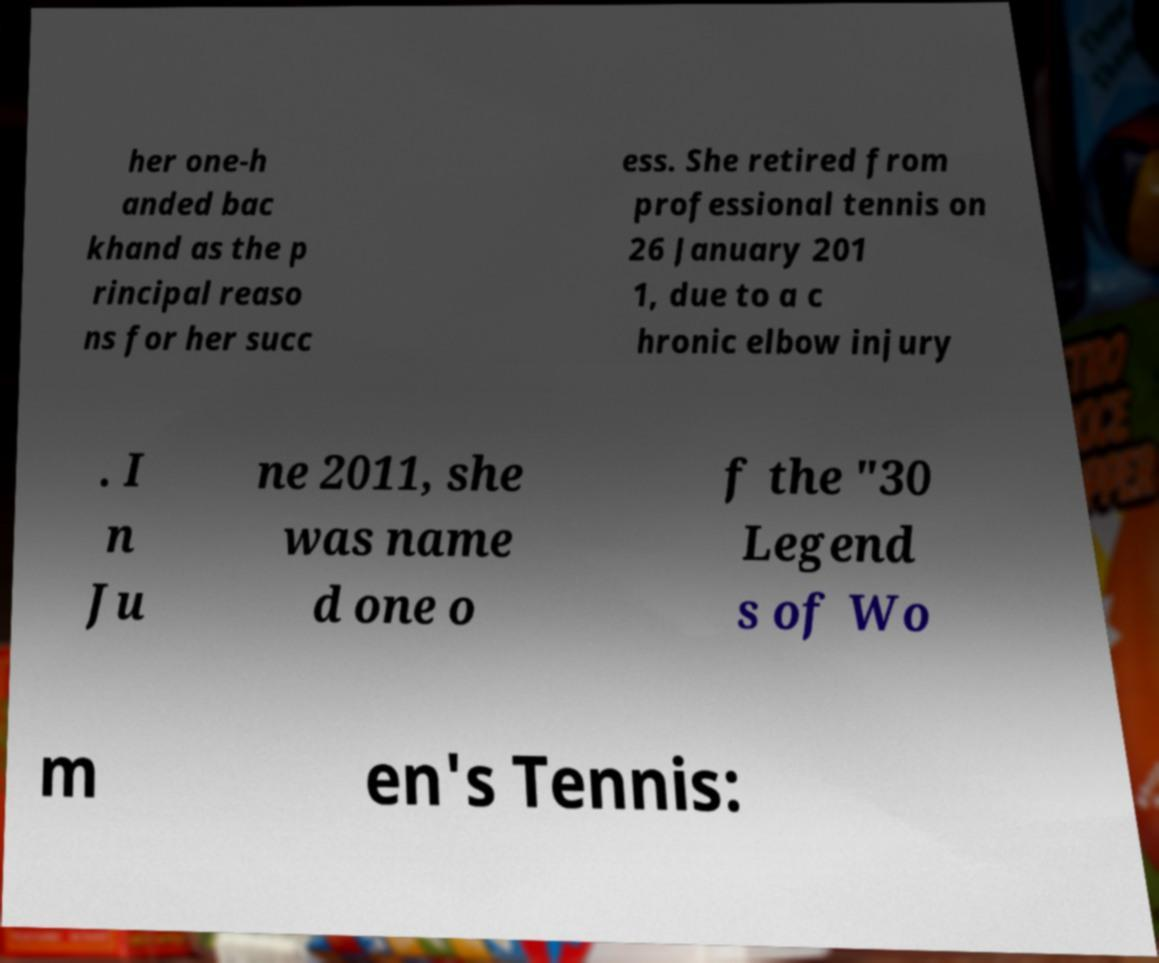Could you extract and type out the text from this image? her one-h anded bac khand as the p rincipal reaso ns for her succ ess. She retired from professional tennis on 26 January 201 1, due to a c hronic elbow injury . I n Ju ne 2011, she was name d one o f the "30 Legend s of Wo m en's Tennis: 